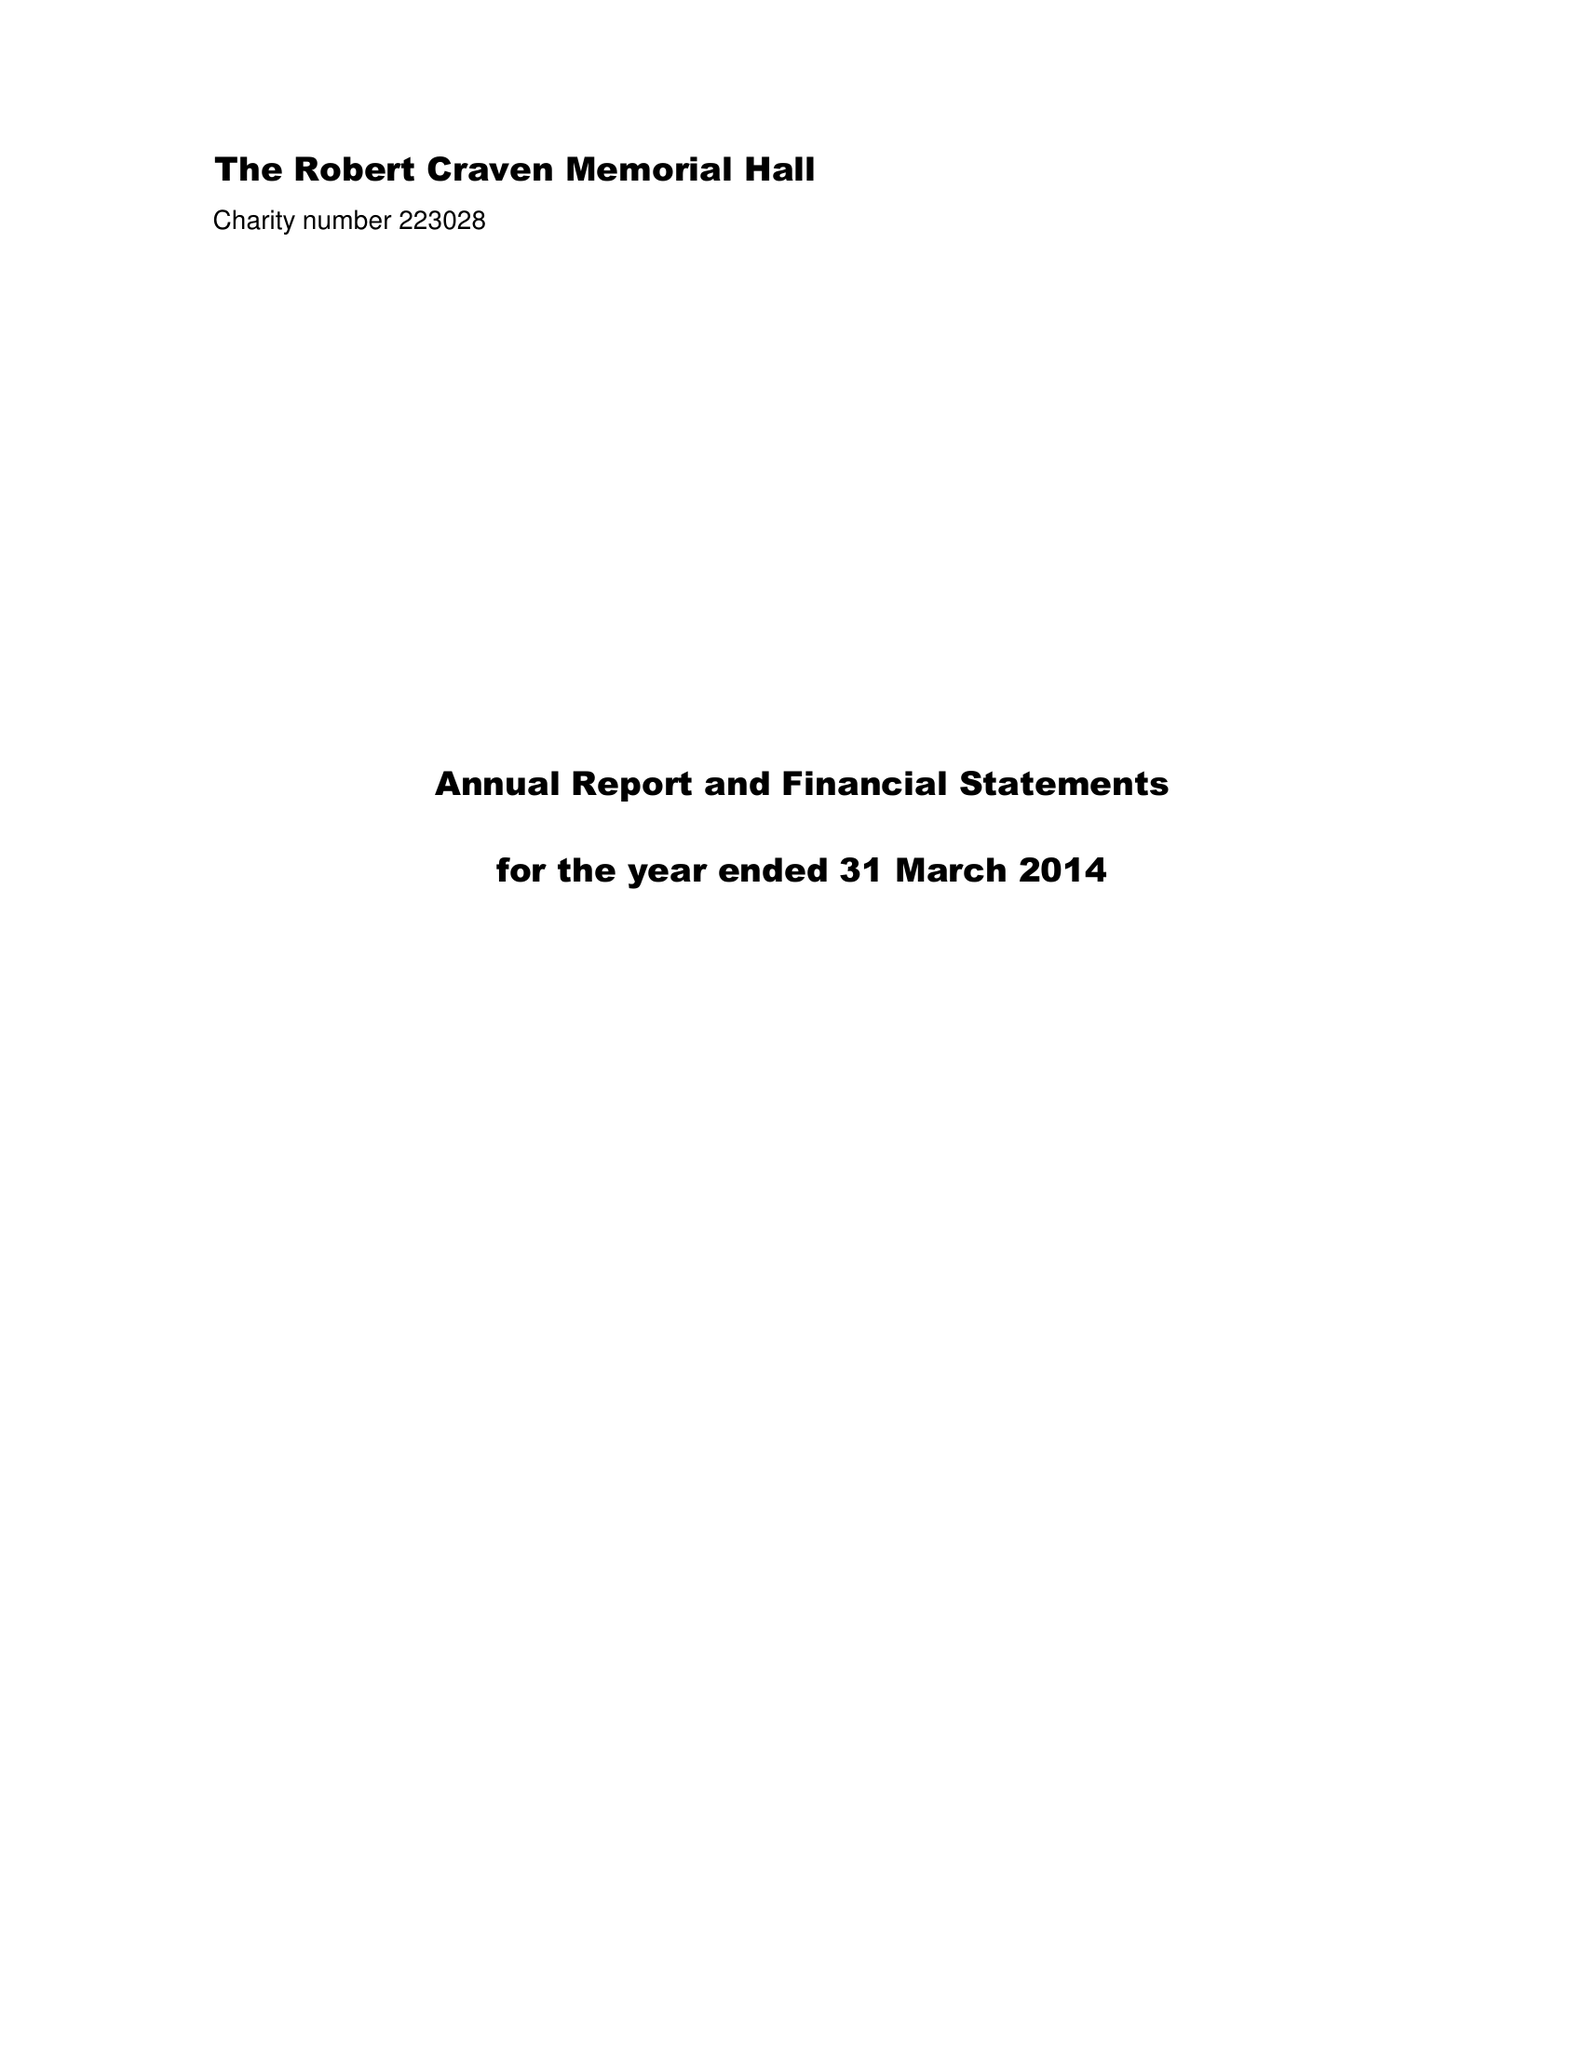What is the value for the spending_annually_in_british_pounds?
Answer the question using a single word or phrase. 36604.00 